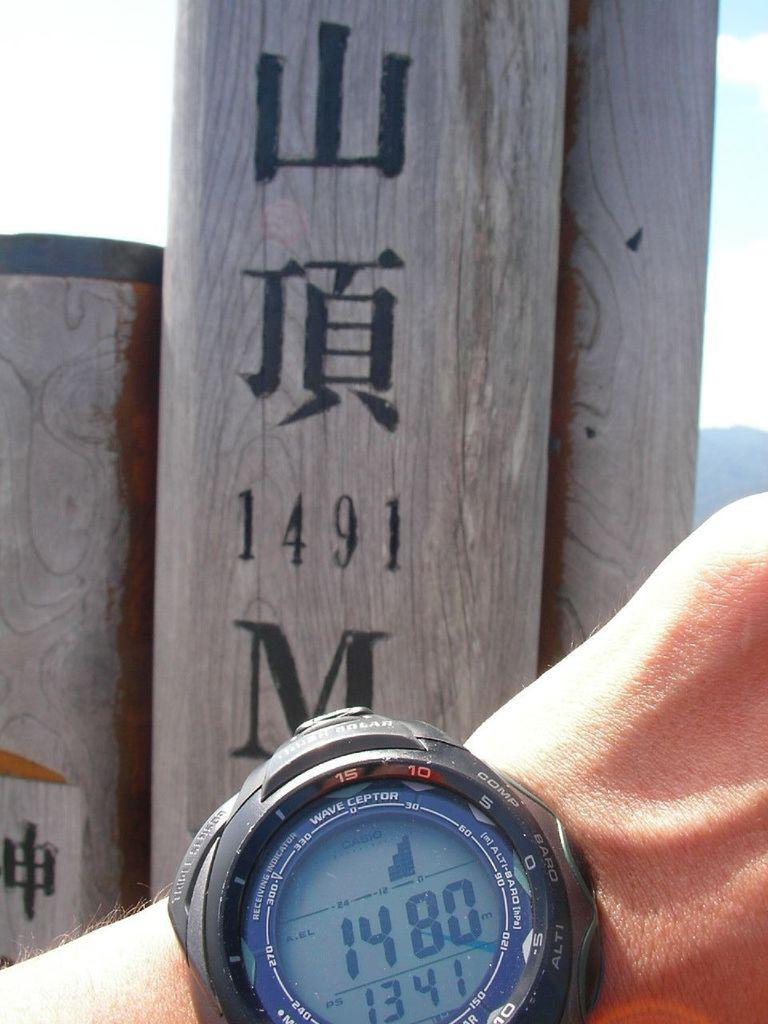<image>
Write a terse but informative summary of the picture. A wrist watch with the time 13 41 on the face 